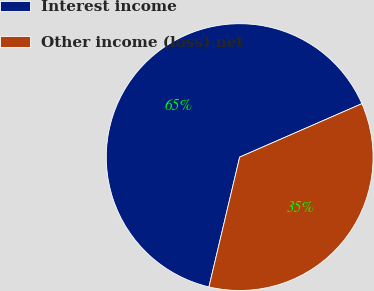<chart> <loc_0><loc_0><loc_500><loc_500><pie_chart><fcel>Interest income<fcel>Other income (loss) net<nl><fcel>64.74%<fcel>35.26%<nl></chart> 